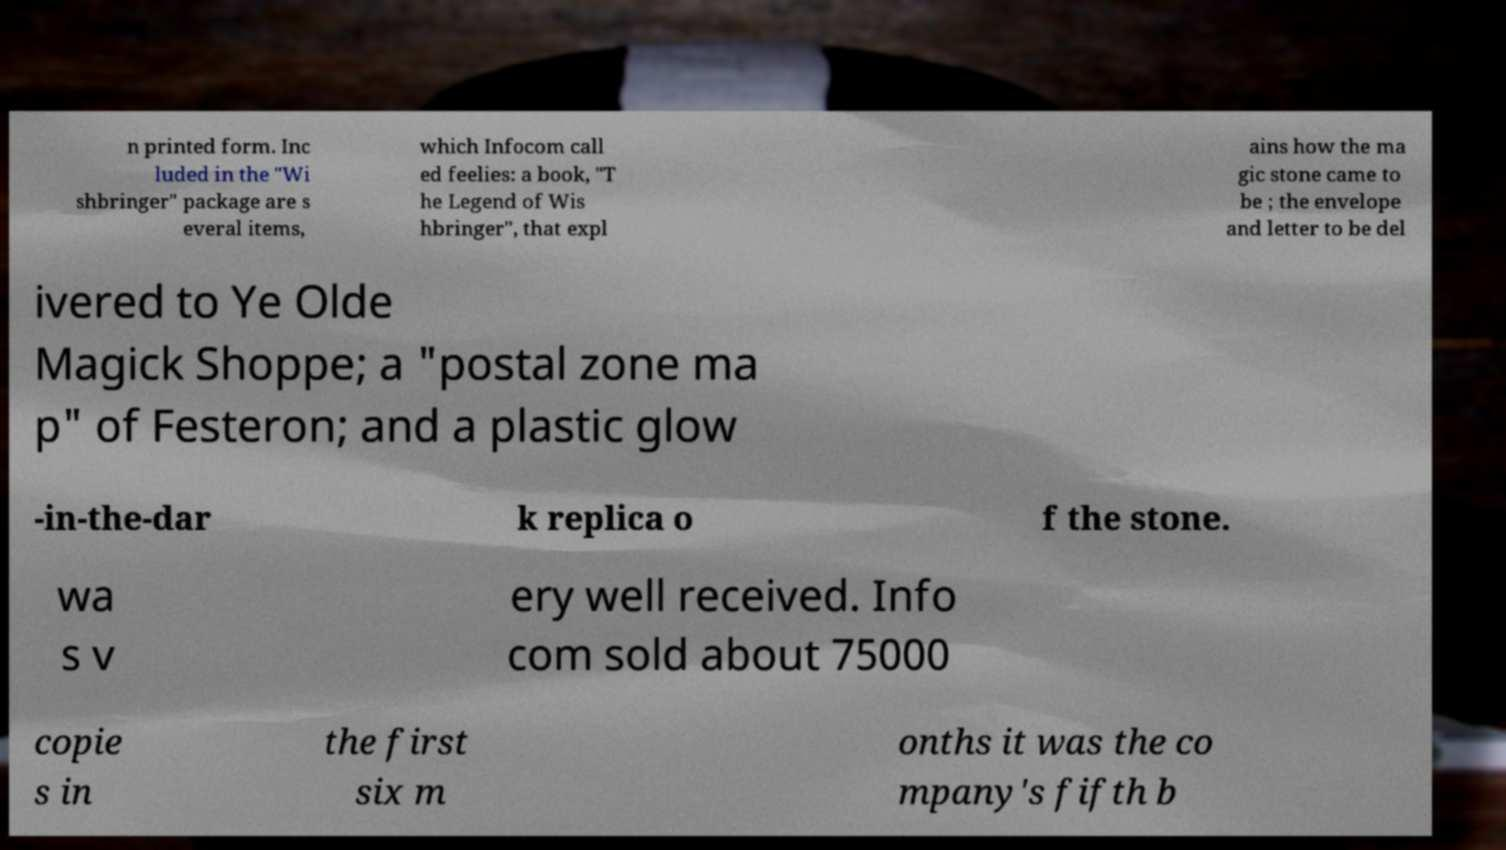Could you assist in decoding the text presented in this image and type it out clearly? n printed form. Inc luded in the "Wi shbringer" package are s everal items, which Infocom call ed feelies: a book, "T he Legend of Wis hbringer", that expl ains how the ma gic stone came to be ; the envelope and letter to be del ivered to Ye Olde Magick Shoppe; a "postal zone ma p" of Festeron; and a plastic glow -in-the-dar k replica o f the stone. wa s v ery well received. Info com sold about 75000 copie s in the first six m onths it was the co mpany's fifth b 